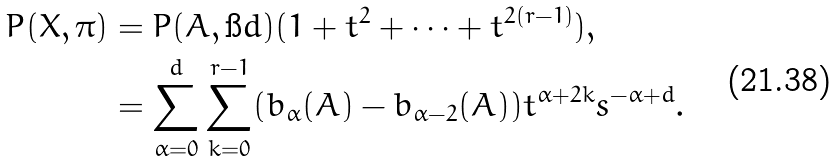Convert formula to latex. <formula><loc_0><loc_0><loc_500><loc_500>P ( X , \pi ) & = P ( A , \i d ) ( 1 + t ^ { 2 } + \cdots + t ^ { 2 ( r - 1 ) } ) , \\ & = \sum _ { \alpha = 0 } ^ { d } \sum _ { k = 0 } ^ { r - 1 } ( b _ { \alpha } ( A ) - b _ { \alpha - 2 } ( A ) ) t ^ { \alpha + 2 k } s ^ { - \alpha + d } .</formula> 